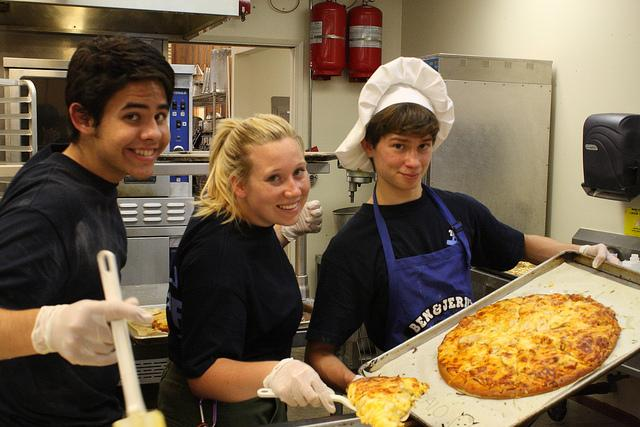How are the three people feeling in the kitchen?

Choices:
A) disappointed
B) angry
C) proud
D) hostile proud 